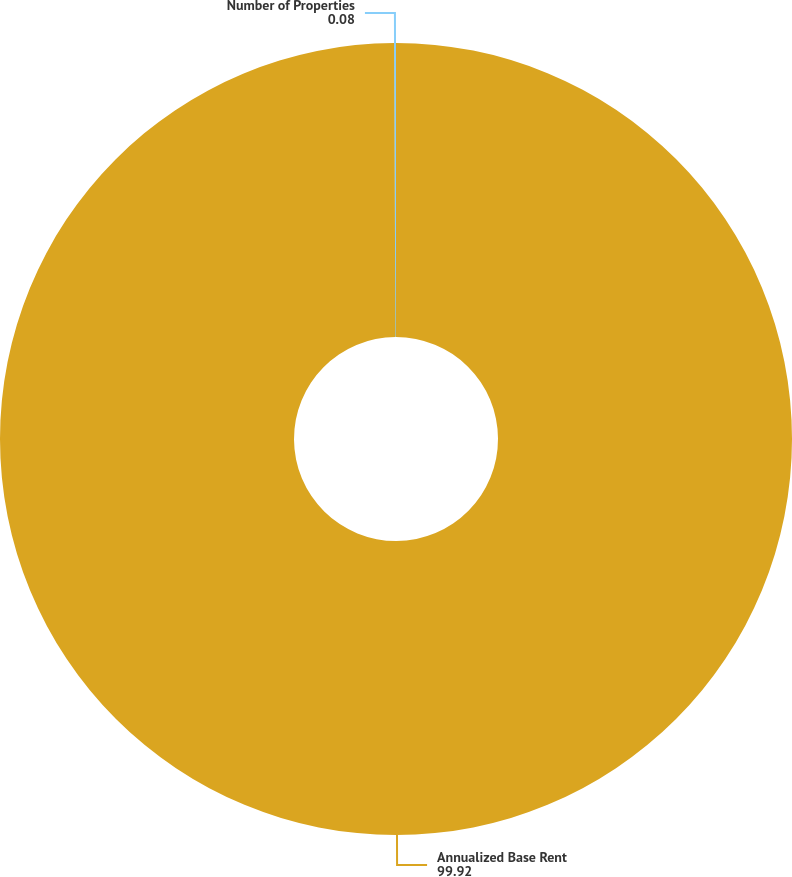Convert chart. <chart><loc_0><loc_0><loc_500><loc_500><pie_chart><fcel>Annualized Base Rent<fcel>Number of Properties<nl><fcel>99.92%<fcel>0.08%<nl></chart> 